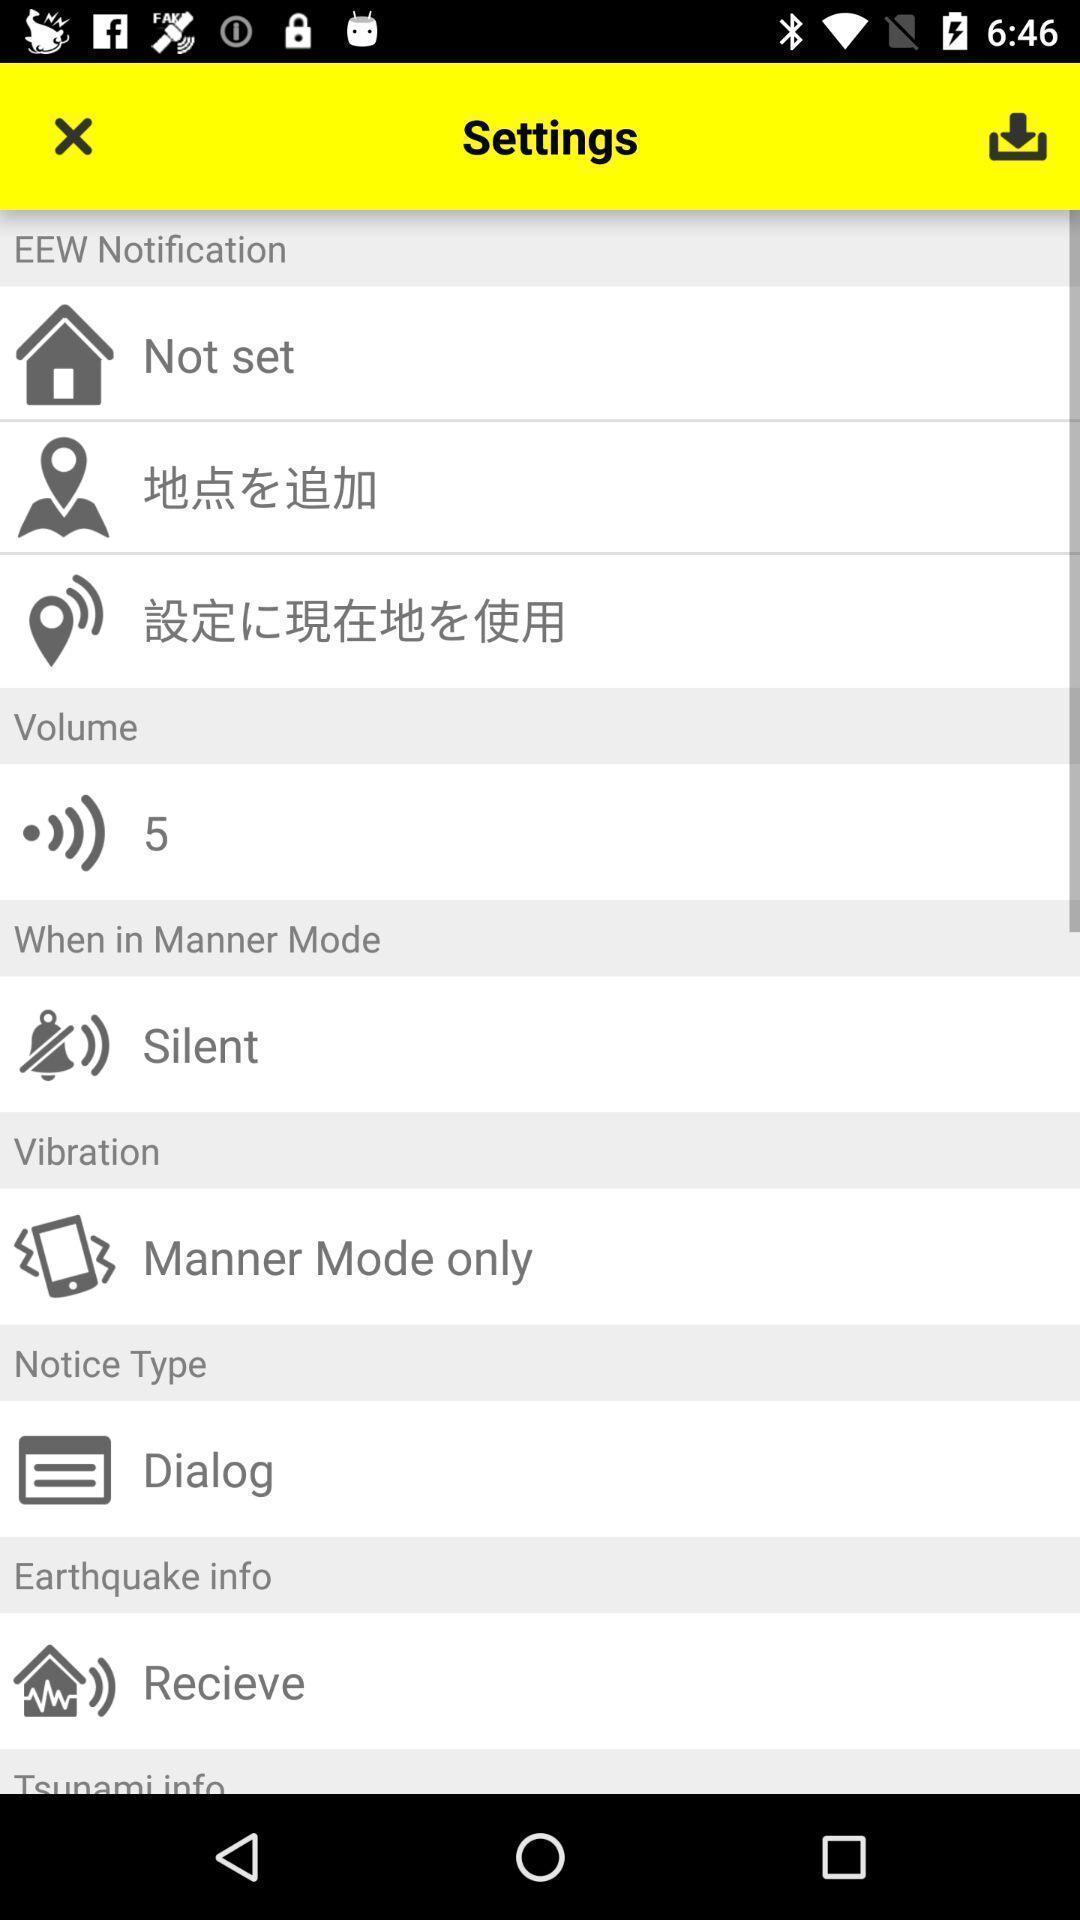Give me a summary of this screen capture. Settings page displayed. 